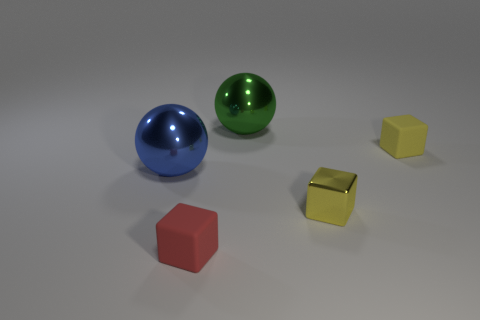Is there any other thing that has the same size as the red cube?
Offer a very short reply. Yes. What size is the ball in front of the yellow rubber thing right of the tiny metallic object?
Keep it short and to the point. Large. Is there anything else that is the same shape as the big blue object?
Make the answer very short. Yes. Is the number of green metallic spheres less than the number of shiny balls?
Keep it short and to the point. Yes. What is the object that is behind the blue object and in front of the green object made of?
Provide a short and direct response. Rubber. Are there any matte objects that are right of the block left of the large green ball?
Give a very brief answer. Yes. What number of things are either small yellow objects or tiny red metal cylinders?
Provide a succinct answer. 2. There is a thing that is left of the large green thing and behind the red thing; what is its shape?
Your response must be concise. Sphere. Is the material of the tiny yellow block in front of the big blue metal sphere the same as the tiny red object?
Make the answer very short. No. What number of objects are small cyan cylinders or matte blocks that are in front of the blue thing?
Ensure brevity in your answer.  1. 